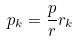Convert formula to latex. <formula><loc_0><loc_0><loc_500><loc_500>p _ { k } = \frac { p } { r } r _ { k }</formula> 